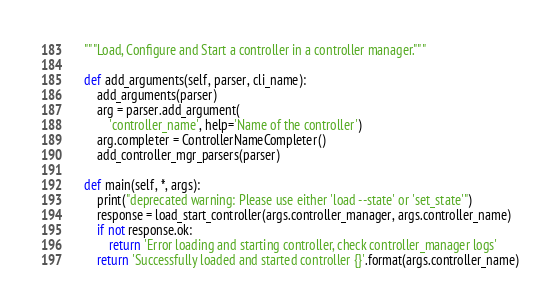Convert code to text. <code><loc_0><loc_0><loc_500><loc_500><_Python_>    """Load, Configure and Start a controller in a controller manager."""

    def add_arguments(self, parser, cli_name):
        add_arguments(parser)
        arg = parser.add_argument(
            'controller_name', help='Name of the controller')
        arg.completer = ControllerNameCompleter()
        add_controller_mgr_parsers(parser)

    def main(self, *, args):
        print("deprecated warning: Please use either 'load --state' or 'set_state'")
        response = load_start_controller(args.controller_manager, args.controller_name)
        if not response.ok:
            return 'Error loading and starting controller, check controller_manager logs'
        return 'Successfully loaded and started controller {}'.format(args.controller_name)
</code> 